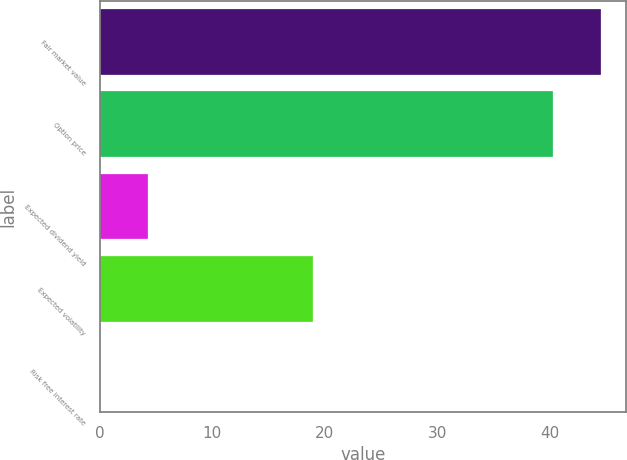<chart> <loc_0><loc_0><loc_500><loc_500><bar_chart><fcel>Fair market value<fcel>Option price<fcel>Expected dividend yield<fcel>Expected volatility<fcel>Risk free interest rate<nl><fcel>44.57<fcel>40.33<fcel>4.29<fcel>19<fcel>0.05<nl></chart> 